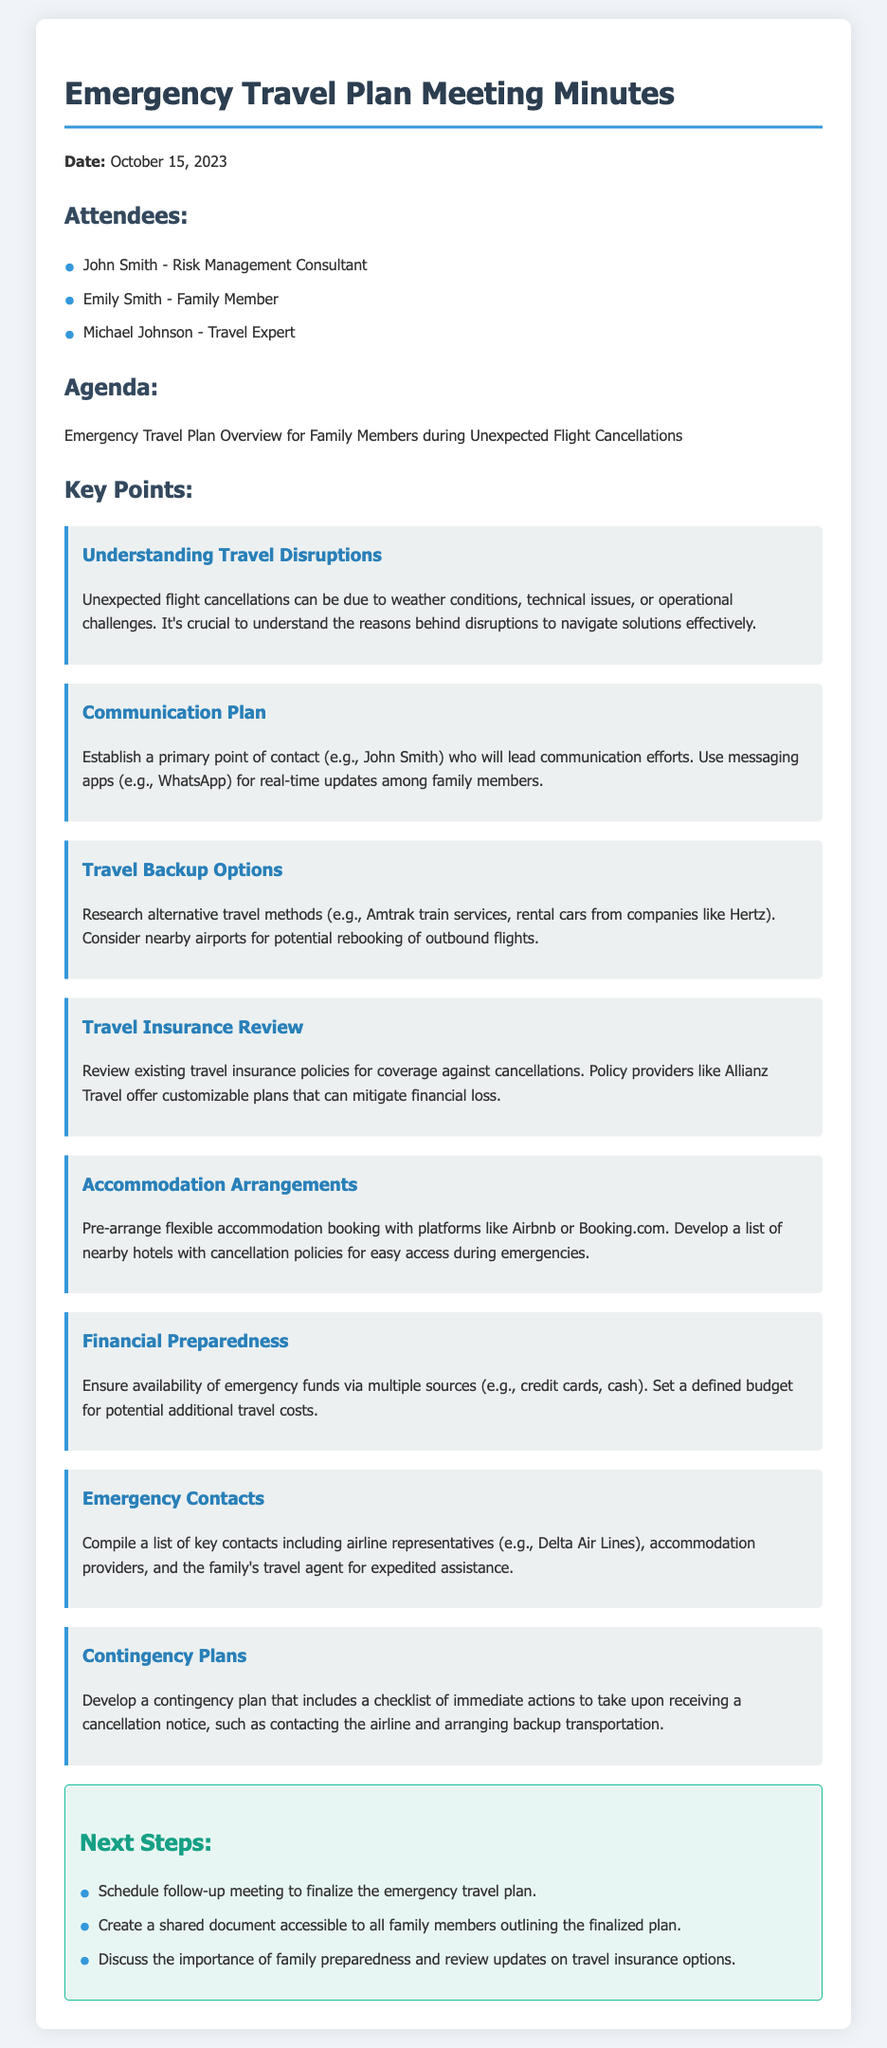What date was the meeting held? The date of the meeting is stated at the beginning of the document as October 15, 2023.
Answer: October 15, 2023 Who is the primary point of contact for communication? The document specifies that John Smith will lead communication efforts during travel disruptions.
Answer: John Smith What are two alternative travel methods mentioned? The document lists Amtrak train services and rental cars as alternative travel options.
Answer: Amtrak train services, rental cars What should be reviewed concerning travel insurance? The document advises reviewing existing travel insurance policies for coverage against cancellations.
Answer: Existing travel insurance policies How many attendees were present at the meeting? The number of attendees can be counted from the list provided in the document, which includes three individuals.
Answer: Three What is one method suggested for financial preparedness? The document mentions ensuring the availability of emergency funds via multiple sources as a financial preparedness strategy.
Answer: Emergency funds via multiple sources What is the next step listed for the family? Among the next steps, scheduling a follow-up meeting to finalize the emergency travel plan is highlighted in the document.
Answer: Schedule follow-up meeting What type of accommodation arrangements should be pre-arranged? The document states that flexible accommodation bookings should be arranged through platforms like Airbnb or Booking.com.
Answer: Flexible accommodation booking 